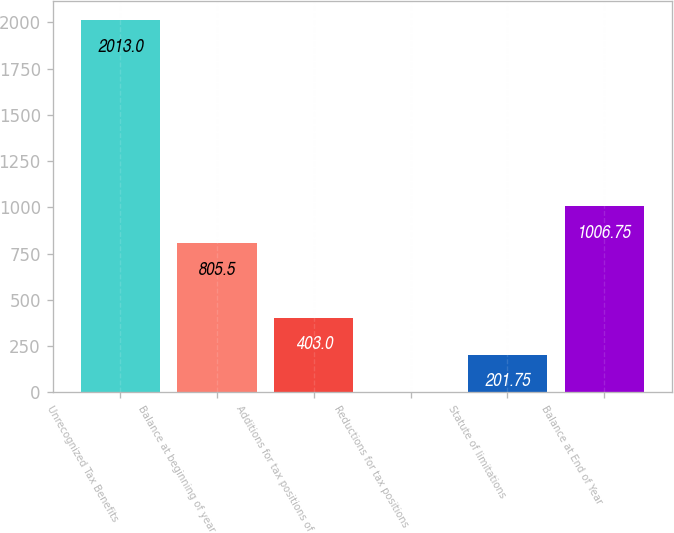<chart> <loc_0><loc_0><loc_500><loc_500><bar_chart><fcel>Unrecognized Tax Benefits<fcel>Balance at beginning of year<fcel>Additions for tax positions of<fcel>Reductions for tax positions<fcel>Statute of limitations<fcel>Balance at End of Year<nl><fcel>2013<fcel>805.5<fcel>403<fcel>0.5<fcel>201.75<fcel>1006.75<nl></chart> 